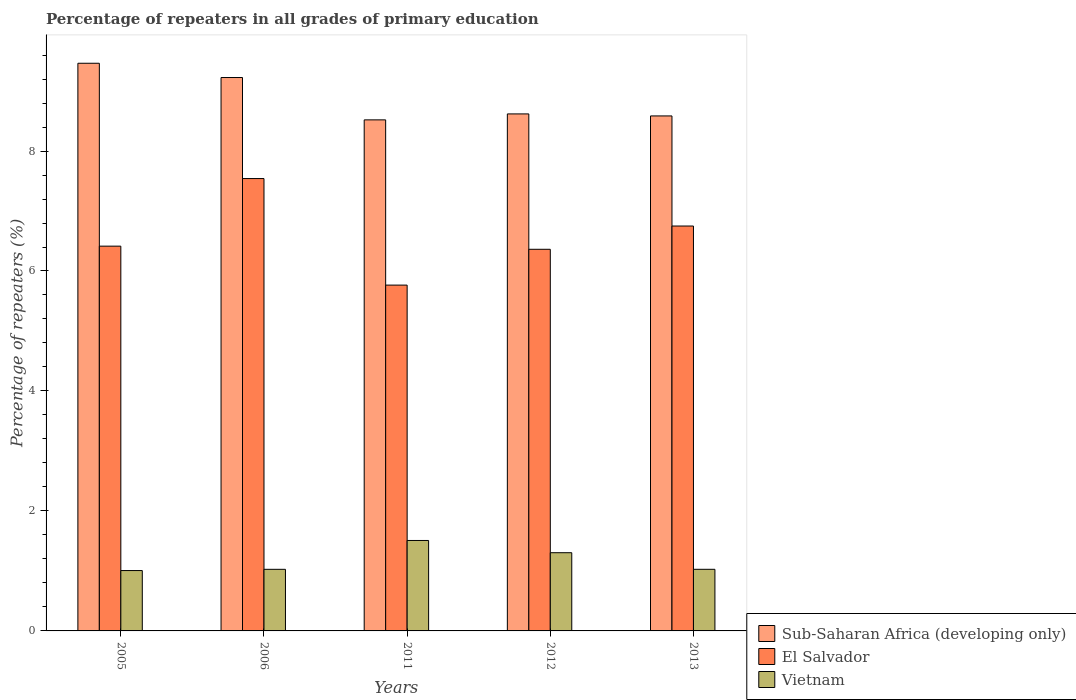How many groups of bars are there?
Your answer should be very brief. 5. How many bars are there on the 1st tick from the left?
Ensure brevity in your answer.  3. How many bars are there on the 5th tick from the right?
Your answer should be compact. 3. What is the label of the 2nd group of bars from the left?
Give a very brief answer. 2006. In how many cases, is the number of bars for a given year not equal to the number of legend labels?
Provide a succinct answer. 0. What is the percentage of repeaters in El Salvador in 2005?
Your answer should be very brief. 6.41. Across all years, what is the maximum percentage of repeaters in Vietnam?
Offer a very short reply. 1.51. Across all years, what is the minimum percentage of repeaters in Sub-Saharan Africa (developing only)?
Offer a very short reply. 8.52. What is the total percentage of repeaters in Vietnam in the graph?
Ensure brevity in your answer.  5.87. What is the difference between the percentage of repeaters in Vietnam in 2006 and that in 2011?
Offer a very short reply. -0.48. What is the difference between the percentage of repeaters in El Salvador in 2006 and the percentage of repeaters in Vietnam in 2013?
Provide a short and direct response. 6.51. What is the average percentage of repeaters in Sub-Saharan Africa (developing only) per year?
Offer a very short reply. 8.88. In the year 2013, what is the difference between the percentage of repeaters in Sub-Saharan Africa (developing only) and percentage of repeaters in Vietnam?
Your answer should be very brief. 7.56. What is the ratio of the percentage of repeaters in Sub-Saharan Africa (developing only) in 2005 to that in 2011?
Provide a short and direct response. 1.11. Is the difference between the percentage of repeaters in Sub-Saharan Africa (developing only) in 2011 and 2012 greater than the difference between the percentage of repeaters in Vietnam in 2011 and 2012?
Your response must be concise. No. What is the difference between the highest and the second highest percentage of repeaters in El Salvador?
Offer a very short reply. 0.79. What is the difference between the highest and the lowest percentage of repeaters in Vietnam?
Offer a terse response. 0.5. In how many years, is the percentage of repeaters in Vietnam greater than the average percentage of repeaters in Vietnam taken over all years?
Keep it short and to the point. 2. Is the sum of the percentage of repeaters in Sub-Saharan Africa (developing only) in 2012 and 2013 greater than the maximum percentage of repeaters in El Salvador across all years?
Provide a succinct answer. Yes. What does the 1st bar from the left in 2006 represents?
Make the answer very short. Sub-Saharan Africa (developing only). What does the 2nd bar from the right in 2012 represents?
Offer a terse response. El Salvador. Is it the case that in every year, the sum of the percentage of repeaters in El Salvador and percentage of repeaters in Vietnam is greater than the percentage of repeaters in Sub-Saharan Africa (developing only)?
Offer a very short reply. No. How many bars are there?
Ensure brevity in your answer.  15. Are all the bars in the graph horizontal?
Keep it short and to the point. No. What is the difference between two consecutive major ticks on the Y-axis?
Offer a very short reply. 2. Are the values on the major ticks of Y-axis written in scientific E-notation?
Give a very brief answer. No. Does the graph contain any zero values?
Offer a very short reply. No. Where does the legend appear in the graph?
Provide a short and direct response. Bottom right. How many legend labels are there?
Offer a very short reply. 3. How are the legend labels stacked?
Your response must be concise. Vertical. What is the title of the graph?
Offer a very short reply. Percentage of repeaters in all grades of primary education. What is the label or title of the X-axis?
Give a very brief answer. Years. What is the label or title of the Y-axis?
Your response must be concise. Percentage of repeaters (%). What is the Percentage of repeaters (%) in Sub-Saharan Africa (developing only) in 2005?
Offer a terse response. 9.46. What is the Percentage of repeaters (%) in El Salvador in 2005?
Offer a very short reply. 6.41. What is the Percentage of repeaters (%) of Vietnam in 2005?
Give a very brief answer. 1.01. What is the Percentage of repeaters (%) of Sub-Saharan Africa (developing only) in 2006?
Offer a terse response. 9.23. What is the Percentage of repeaters (%) of El Salvador in 2006?
Offer a terse response. 7.54. What is the Percentage of repeaters (%) in Vietnam in 2006?
Ensure brevity in your answer.  1.03. What is the Percentage of repeaters (%) in Sub-Saharan Africa (developing only) in 2011?
Keep it short and to the point. 8.52. What is the Percentage of repeaters (%) of El Salvador in 2011?
Offer a very short reply. 5.76. What is the Percentage of repeaters (%) in Vietnam in 2011?
Your answer should be compact. 1.51. What is the Percentage of repeaters (%) of Sub-Saharan Africa (developing only) in 2012?
Make the answer very short. 8.62. What is the Percentage of repeaters (%) in El Salvador in 2012?
Your answer should be compact. 6.36. What is the Percentage of repeaters (%) in Vietnam in 2012?
Provide a short and direct response. 1.3. What is the Percentage of repeaters (%) of Sub-Saharan Africa (developing only) in 2013?
Offer a very short reply. 8.59. What is the Percentage of repeaters (%) of El Salvador in 2013?
Your answer should be very brief. 6.75. What is the Percentage of repeaters (%) of Vietnam in 2013?
Provide a succinct answer. 1.03. Across all years, what is the maximum Percentage of repeaters (%) in Sub-Saharan Africa (developing only)?
Provide a short and direct response. 9.46. Across all years, what is the maximum Percentage of repeaters (%) in El Salvador?
Offer a terse response. 7.54. Across all years, what is the maximum Percentage of repeaters (%) in Vietnam?
Offer a very short reply. 1.51. Across all years, what is the minimum Percentage of repeaters (%) of Sub-Saharan Africa (developing only)?
Provide a short and direct response. 8.52. Across all years, what is the minimum Percentage of repeaters (%) in El Salvador?
Provide a succinct answer. 5.76. Across all years, what is the minimum Percentage of repeaters (%) in Vietnam?
Your answer should be compact. 1.01. What is the total Percentage of repeaters (%) of Sub-Saharan Africa (developing only) in the graph?
Your answer should be compact. 44.41. What is the total Percentage of repeaters (%) in El Salvador in the graph?
Give a very brief answer. 32.83. What is the total Percentage of repeaters (%) of Vietnam in the graph?
Your answer should be very brief. 5.87. What is the difference between the Percentage of repeaters (%) in Sub-Saharan Africa (developing only) in 2005 and that in 2006?
Provide a short and direct response. 0.24. What is the difference between the Percentage of repeaters (%) in El Salvador in 2005 and that in 2006?
Make the answer very short. -1.13. What is the difference between the Percentage of repeaters (%) in Vietnam in 2005 and that in 2006?
Your answer should be very brief. -0.02. What is the difference between the Percentage of repeaters (%) of Sub-Saharan Africa (developing only) in 2005 and that in 2011?
Your response must be concise. 0.94. What is the difference between the Percentage of repeaters (%) of El Salvador in 2005 and that in 2011?
Provide a succinct answer. 0.65. What is the difference between the Percentage of repeaters (%) in Vietnam in 2005 and that in 2011?
Offer a terse response. -0.5. What is the difference between the Percentage of repeaters (%) in Sub-Saharan Africa (developing only) in 2005 and that in 2012?
Offer a very short reply. 0.84. What is the difference between the Percentage of repeaters (%) in El Salvador in 2005 and that in 2012?
Provide a succinct answer. 0.05. What is the difference between the Percentage of repeaters (%) in Vietnam in 2005 and that in 2012?
Provide a short and direct response. -0.3. What is the difference between the Percentage of repeaters (%) in Sub-Saharan Africa (developing only) in 2005 and that in 2013?
Ensure brevity in your answer.  0.88. What is the difference between the Percentage of repeaters (%) in El Salvador in 2005 and that in 2013?
Provide a short and direct response. -0.34. What is the difference between the Percentage of repeaters (%) of Vietnam in 2005 and that in 2013?
Provide a succinct answer. -0.02. What is the difference between the Percentage of repeaters (%) of Sub-Saharan Africa (developing only) in 2006 and that in 2011?
Keep it short and to the point. 0.71. What is the difference between the Percentage of repeaters (%) of El Salvador in 2006 and that in 2011?
Provide a short and direct response. 1.78. What is the difference between the Percentage of repeaters (%) in Vietnam in 2006 and that in 2011?
Give a very brief answer. -0.48. What is the difference between the Percentage of repeaters (%) of Sub-Saharan Africa (developing only) in 2006 and that in 2012?
Provide a succinct answer. 0.61. What is the difference between the Percentage of repeaters (%) in El Salvador in 2006 and that in 2012?
Provide a succinct answer. 1.18. What is the difference between the Percentage of repeaters (%) in Vietnam in 2006 and that in 2012?
Your answer should be very brief. -0.28. What is the difference between the Percentage of repeaters (%) of Sub-Saharan Africa (developing only) in 2006 and that in 2013?
Make the answer very short. 0.64. What is the difference between the Percentage of repeaters (%) in El Salvador in 2006 and that in 2013?
Offer a terse response. 0.79. What is the difference between the Percentage of repeaters (%) in Vietnam in 2006 and that in 2013?
Provide a short and direct response. -0. What is the difference between the Percentage of repeaters (%) in Sub-Saharan Africa (developing only) in 2011 and that in 2012?
Provide a short and direct response. -0.1. What is the difference between the Percentage of repeaters (%) of El Salvador in 2011 and that in 2012?
Offer a terse response. -0.6. What is the difference between the Percentage of repeaters (%) of Vietnam in 2011 and that in 2012?
Make the answer very short. 0.2. What is the difference between the Percentage of repeaters (%) in Sub-Saharan Africa (developing only) in 2011 and that in 2013?
Make the answer very short. -0.07. What is the difference between the Percentage of repeaters (%) in El Salvador in 2011 and that in 2013?
Your answer should be very brief. -0.98. What is the difference between the Percentage of repeaters (%) in Vietnam in 2011 and that in 2013?
Provide a short and direct response. 0.48. What is the difference between the Percentage of repeaters (%) of Sub-Saharan Africa (developing only) in 2012 and that in 2013?
Provide a short and direct response. 0.03. What is the difference between the Percentage of repeaters (%) in El Salvador in 2012 and that in 2013?
Make the answer very short. -0.39. What is the difference between the Percentage of repeaters (%) of Vietnam in 2012 and that in 2013?
Your answer should be compact. 0.28. What is the difference between the Percentage of repeaters (%) in Sub-Saharan Africa (developing only) in 2005 and the Percentage of repeaters (%) in El Salvador in 2006?
Provide a short and direct response. 1.92. What is the difference between the Percentage of repeaters (%) of Sub-Saharan Africa (developing only) in 2005 and the Percentage of repeaters (%) of Vietnam in 2006?
Make the answer very short. 8.44. What is the difference between the Percentage of repeaters (%) in El Salvador in 2005 and the Percentage of repeaters (%) in Vietnam in 2006?
Your answer should be compact. 5.39. What is the difference between the Percentage of repeaters (%) in Sub-Saharan Africa (developing only) in 2005 and the Percentage of repeaters (%) in El Salvador in 2011?
Make the answer very short. 3.7. What is the difference between the Percentage of repeaters (%) in Sub-Saharan Africa (developing only) in 2005 and the Percentage of repeaters (%) in Vietnam in 2011?
Your answer should be very brief. 7.96. What is the difference between the Percentage of repeaters (%) in El Salvador in 2005 and the Percentage of repeaters (%) in Vietnam in 2011?
Offer a terse response. 4.91. What is the difference between the Percentage of repeaters (%) of Sub-Saharan Africa (developing only) in 2005 and the Percentage of repeaters (%) of El Salvador in 2012?
Provide a succinct answer. 3.1. What is the difference between the Percentage of repeaters (%) in Sub-Saharan Africa (developing only) in 2005 and the Percentage of repeaters (%) in Vietnam in 2012?
Keep it short and to the point. 8.16. What is the difference between the Percentage of repeaters (%) of El Salvador in 2005 and the Percentage of repeaters (%) of Vietnam in 2012?
Your response must be concise. 5.11. What is the difference between the Percentage of repeaters (%) in Sub-Saharan Africa (developing only) in 2005 and the Percentage of repeaters (%) in El Salvador in 2013?
Offer a very short reply. 2.71. What is the difference between the Percentage of repeaters (%) in Sub-Saharan Africa (developing only) in 2005 and the Percentage of repeaters (%) in Vietnam in 2013?
Your answer should be compact. 8.44. What is the difference between the Percentage of repeaters (%) of El Salvador in 2005 and the Percentage of repeaters (%) of Vietnam in 2013?
Offer a very short reply. 5.39. What is the difference between the Percentage of repeaters (%) in Sub-Saharan Africa (developing only) in 2006 and the Percentage of repeaters (%) in El Salvador in 2011?
Make the answer very short. 3.46. What is the difference between the Percentage of repeaters (%) of Sub-Saharan Africa (developing only) in 2006 and the Percentage of repeaters (%) of Vietnam in 2011?
Give a very brief answer. 7.72. What is the difference between the Percentage of repeaters (%) of El Salvador in 2006 and the Percentage of repeaters (%) of Vietnam in 2011?
Provide a short and direct response. 6.03. What is the difference between the Percentage of repeaters (%) in Sub-Saharan Africa (developing only) in 2006 and the Percentage of repeaters (%) in El Salvador in 2012?
Provide a succinct answer. 2.86. What is the difference between the Percentage of repeaters (%) in Sub-Saharan Africa (developing only) in 2006 and the Percentage of repeaters (%) in Vietnam in 2012?
Your answer should be compact. 7.92. What is the difference between the Percentage of repeaters (%) in El Salvador in 2006 and the Percentage of repeaters (%) in Vietnam in 2012?
Provide a short and direct response. 6.24. What is the difference between the Percentage of repeaters (%) of Sub-Saharan Africa (developing only) in 2006 and the Percentage of repeaters (%) of El Salvador in 2013?
Keep it short and to the point. 2.48. What is the difference between the Percentage of repeaters (%) in Sub-Saharan Africa (developing only) in 2006 and the Percentage of repeaters (%) in Vietnam in 2013?
Provide a succinct answer. 8.2. What is the difference between the Percentage of repeaters (%) in El Salvador in 2006 and the Percentage of repeaters (%) in Vietnam in 2013?
Your response must be concise. 6.51. What is the difference between the Percentage of repeaters (%) of Sub-Saharan Africa (developing only) in 2011 and the Percentage of repeaters (%) of El Salvador in 2012?
Give a very brief answer. 2.16. What is the difference between the Percentage of repeaters (%) in Sub-Saharan Africa (developing only) in 2011 and the Percentage of repeaters (%) in Vietnam in 2012?
Make the answer very short. 7.22. What is the difference between the Percentage of repeaters (%) of El Salvador in 2011 and the Percentage of repeaters (%) of Vietnam in 2012?
Your response must be concise. 4.46. What is the difference between the Percentage of repeaters (%) in Sub-Saharan Africa (developing only) in 2011 and the Percentage of repeaters (%) in El Salvador in 2013?
Your response must be concise. 1.77. What is the difference between the Percentage of repeaters (%) of Sub-Saharan Africa (developing only) in 2011 and the Percentage of repeaters (%) of Vietnam in 2013?
Give a very brief answer. 7.49. What is the difference between the Percentage of repeaters (%) in El Salvador in 2011 and the Percentage of repeaters (%) in Vietnam in 2013?
Your response must be concise. 4.74. What is the difference between the Percentage of repeaters (%) of Sub-Saharan Africa (developing only) in 2012 and the Percentage of repeaters (%) of El Salvador in 2013?
Provide a short and direct response. 1.87. What is the difference between the Percentage of repeaters (%) of Sub-Saharan Africa (developing only) in 2012 and the Percentage of repeaters (%) of Vietnam in 2013?
Ensure brevity in your answer.  7.59. What is the difference between the Percentage of repeaters (%) of El Salvador in 2012 and the Percentage of repeaters (%) of Vietnam in 2013?
Your response must be concise. 5.33. What is the average Percentage of repeaters (%) of Sub-Saharan Africa (developing only) per year?
Your response must be concise. 8.88. What is the average Percentage of repeaters (%) in El Salvador per year?
Your answer should be very brief. 6.57. What is the average Percentage of repeaters (%) in Vietnam per year?
Provide a short and direct response. 1.17. In the year 2005, what is the difference between the Percentage of repeaters (%) in Sub-Saharan Africa (developing only) and Percentage of repeaters (%) in El Salvador?
Your answer should be very brief. 3.05. In the year 2005, what is the difference between the Percentage of repeaters (%) in Sub-Saharan Africa (developing only) and Percentage of repeaters (%) in Vietnam?
Your answer should be compact. 8.46. In the year 2005, what is the difference between the Percentage of repeaters (%) in El Salvador and Percentage of repeaters (%) in Vietnam?
Provide a short and direct response. 5.41. In the year 2006, what is the difference between the Percentage of repeaters (%) in Sub-Saharan Africa (developing only) and Percentage of repeaters (%) in El Salvador?
Your answer should be compact. 1.68. In the year 2006, what is the difference between the Percentage of repeaters (%) in Sub-Saharan Africa (developing only) and Percentage of repeaters (%) in Vietnam?
Give a very brief answer. 8.2. In the year 2006, what is the difference between the Percentage of repeaters (%) in El Salvador and Percentage of repeaters (%) in Vietnam?
Your answer should be compact. 6.51. In the year 2011, what is the difference between the Percentage of repeaters (%) of Sub-Saharan Africa (developing only) and Percentage of repeaters (%) of El Salvador?
Offer a terse response. 2.75. In the year 2011, what is the difference between the Percentage of repeaters (%) of Sub-Saharan Africa (developing only) and Percentage of repeaters (%) of Vietnam?
Ensure brevity in your answer.  7.01. In the year 2011, what is the difference between the Percentage of repeaters (%) of El Salvador and Percentage of repeaters (%) of Vietnam?
Your answer should be compact. 4.26. In the year 2012, what is the difference between the Percentage of repeaters (%) in Sub-Saharan Africa (developing only) and Percentage of repeaters (%) in El Salvador?
Your answer should be very brief. 2.26. In the year 2012, what is the difference between the Percentage of repeaters (%) in Sub-Saharan Africa (developing only) and Percentage of repeaters (%) in Vietnam?
Make the answer very short. 7.31. In the year 2012, what is the difference between the Percentage of repeaters (%) in El Salvador and Percentage of repeaters (%) in Vietnam?
Offer a very short reply. 5.06. In the year 2013, what is the difference between the Percentage of repeaters (%) in Sub-Saharan Africa (developing only) and Percentage of repeaters (%) in El Salvador?
Your response must be concise. 1.84. In the year 2013, what is the difference between the Percentage of repeaters (%) of Sub-Saharan Africa (developing only) and Percentage of repeaters (%) of Vietnam?
Your answer should be compact. 7.56. In the year 2013, what is the difference between the Percentage of repeaters (%) of El Salvador and Percentage of repeaters (%) of Vietnam?
Ensure brevity in your answer.  5.72. What is the ratio of the Percentage of repeaters (%) in Sub-Saharan Africa (developing only) in 2005 to that in 2006?
Your answer should be very brief. 1.03. What is the ratio of the Percentage of repeaters (%) of El Salvador in 2005 to that in 2006?
Make the answer very short. 0.85. What is the ratio of the Percentage of repeaters (%) in Vietnam in 2005 to that in 2006?
Provide a short and direct response. 0.98. What is the ratio of the Percentage of repeaters (%) in Sub-Saharan Africa (developing only) in 2005 to that in 2011?
Make the answer very short. 1.11. What is the ratio of the Percentage of repeaters (%) of El Salvador in 2005 to that in 2011?
Make the answer very short. 1.11. What is the ratio of the Percentage of repeaters (%) of Vietnam in 2005 to that in 2011?
Keep it short and to the point. 0.67. What is the ratio of the Percentage of repeaters (%) of Sub-Saharan Africa (developing only) in 2005 to that in 2012?
Provide a short and direct response. 1.1. What is the ratio of the Percentage of repeaters (%) in El Salvador in 2005 to that in 2012?
Offer a very short reply. 1.01. What is the ratio of the Percentage of repeaters (%) in Vietnam in 2005 to that in 2012?
Provide a succinct answer. 0.77. What is the ratio of the Percentage of repeaters (%) in Sub-Saharan Africa (developing only) in 2005 to that in 2013?
Provide a succinct answer. 1.1. What is the ratio of the Percentage of repeaters (%) in El Salvador in 2005 to that in 2013?
Provide a short and direct response. 0.95. What is the ratio of the Percentage of repeaters (%) of Vietnam in 2005 to that in 2013?
Give a very brief answer. 0.98. What is the ratio of the Percentage of repeaters (%) of Sub-Saharan Africa (developing only) in 2006 to that in 2011?
Your answer should be very brief. 1.08. What is the ratio of the Percentage of repeaters (%) of El Salvador in 2006 to that in 2011?
Make the answer very short. 1.31. What is the ratio of the Percentage of repeaters (%) in Vietnam in 2006 to that in 2011?
Ensure brevity in your answer.  0.68. What is the ratio of the Percentage of repeaters (%) in Sub-Saharan Africa (developing only) in 2006 to that in 2012?
Offer a very short reply. 1.07. What is the ratio of the Percentage of repeaters (%) in El Salvador in 2006 to that in 2012?
Offer a very short reply. 1.19. What is the ratio of the Percentage of repeaters (%) of Vietnam in 2006 to that in 2012?
Your response must be concise. 0.79. What is the ratio of the Percentage of repeaters (%) in Sub-Saharan Africa (developing only) in 2006 to that in 2013?
Offer a very short reply. 1.07. What is the ratio of the Percentage of repeaters (%) of El Salvador in 2006 to that in 2013?
Give a very brief answer. 1.12. What is the ratio of the Percentage of repeaters (%) in Sub-Saharan Africa (developing only) in 2011 to that in 2012?
Offer a terse response. 0.99. What is the ratio of the Percentage of repeaters (%) in El Salvador in 2011 to that in 2012?
Make the answer very short. 0.91. What is the ratio of the Percentage of repeaters (%) in Vietnam in 2011 to that in 2012?
Provide a succinct answer. 1.16. What is the ratio of the Percentage of repeaters (%) of El Salvador in 2011 to that in 2013?
Your response must be concise. 0.85. What is the ratio of the Percentage of repeaters (%) of Vietnam in 2011 to that in 2013?
Offer a terse response. 1.47. What is the ratio of the Percentage of repeaters (%) of Sub-Saharan Africa (developing only) in 2012 to that in 2013?
Keep it short and to the point. 1. What is the ratio of the Percentage of repeaters (%) of El Salvador in 2012 to that in 2013?
Make the answer very short. 0.94. What is the ratio of the Percentage of repeaters (%) in Vietnam in 2012 to that in 2013?
Provide a short and direct response. 1.27. What is the difference between the highest and the second highest Percentage of repeaters (%) in Sub-Saharan Africa (developing only)?
Provide a succinct answer. 0.24. What is the difference between the highest and the second highest Percentage of repeaters (%) in El Salvador?
Ensure brevity in your answer.  0.79. What is the difference between the highest and the second highest Percentage of repeaters (%) of Vietnam?
Give a very brief answer. 0.2. What is the difference between the highest and the lowest Percentage of repeaters (%) of Sub-Saharan Africa (developing only)?
Provide a short and direct response. 0.94. What is the difference between the highest and the lowest Percentage of repeaters (%) of El Salvador?
Offer a terse response. 1.78. What is the difference between the highest and the lowest Percentage of repeaters (%) in Vietnam?
Offer a very short reply. 0.5. 